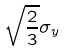<formula> <loc_0><loc_0><loc_500><loc_500>\sqrt { \frac { 2 } { 3 } } \sigma _ { y }</formula> 